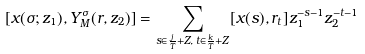<formula> <loc_0><loc_0><loc_500><loc_500>[ x ( \sigma ; z _ { 1 } ) , Y _ { M } ^ { \sigma } ( r , z _ { 2 } ) ] = \sum _ { s \in \frac { j } { T } + Z , \, t \in \frac { k } { T } + Z } [ x ( s ) , r _ { t } ] z _ { 1 } ^ { - s - 1 } z _ { 2 } ^ { - t - 1 }</formula> 